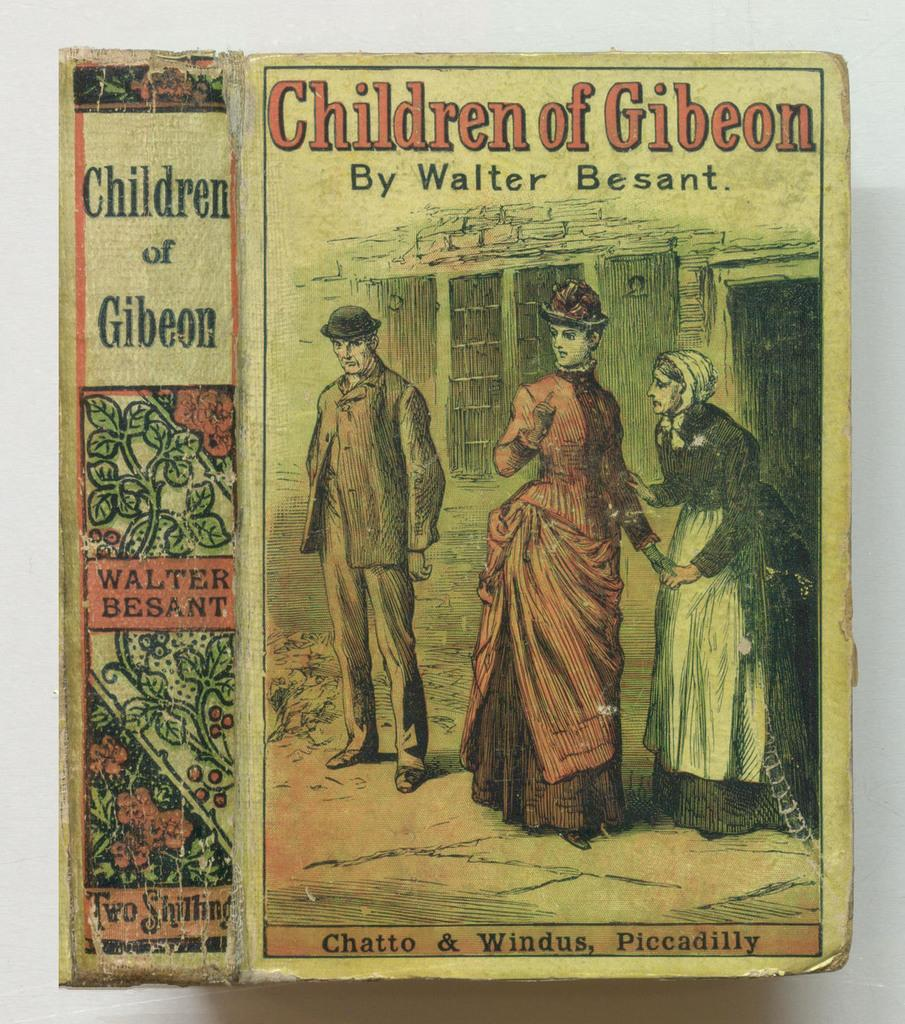What type of image is present in the picture? There is a cartoon image in the picture. What might the cartoon image be used for? The cartoon image appears to be the cover page of a book. What else can be seen along with the cartoon image? There is text associated with the cartoon image. What language is the person speaking in the image? There is no person present in the image, and therefore no speech or language can be observed. 